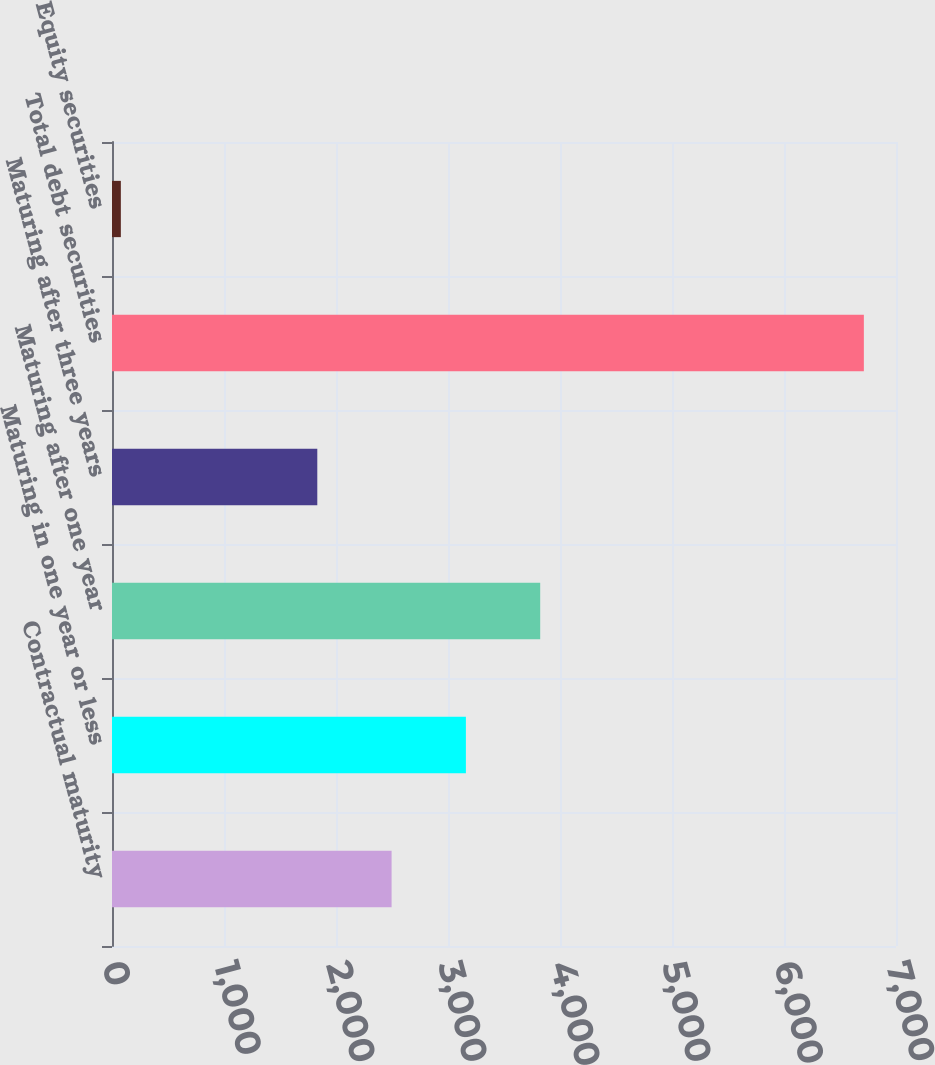Convert chart to OTSL. <chart><loc_0><loc_0><loc_500><loc_500><bar_chart><fcel>Contractual maturity<fcel>Maturing in one year or less<fcel>Maturing after one year<fcel>Maturing after three years<fcel>Total debt securities<fcel>Equity securities<nl><fcel>2496.4<fcel>3159.8<fcel>3823.2<fcel>1833<fcel>6713<fcel>79<nl></chart> 